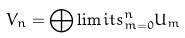Convert formula to latex. <formula><loc_0><loc_0><loc_500><loc_500>V _ { n } = \bigoplus \lim i t s ^ { n } _ { m = 0 } U _ { m }</formula> 